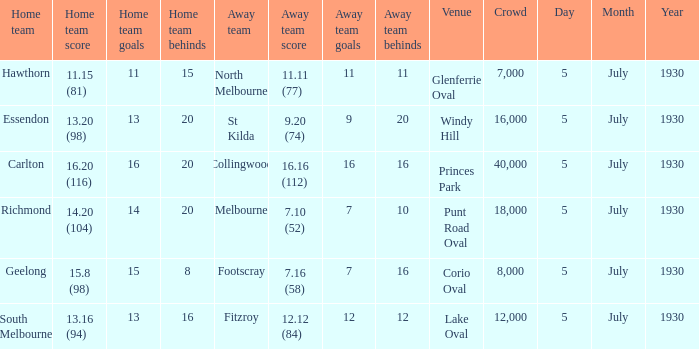Who is the away side at corio oval? Footscray. 